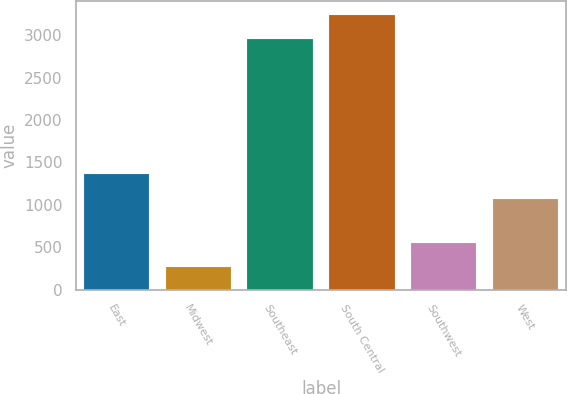Convert chart to OTSL. <chart><loc_0><loc_0><loc_500><loc_500><bar_chart><fcel>East<fcel>Midwest<fcel>Southeast<fcel>South Central<fcel>Southwest<fcel>West<nl><fcel>1358.5<fcel>271<fcel>2955<fcel>3241.5<fcel>557.5<fcel>1072<nl></chart> 